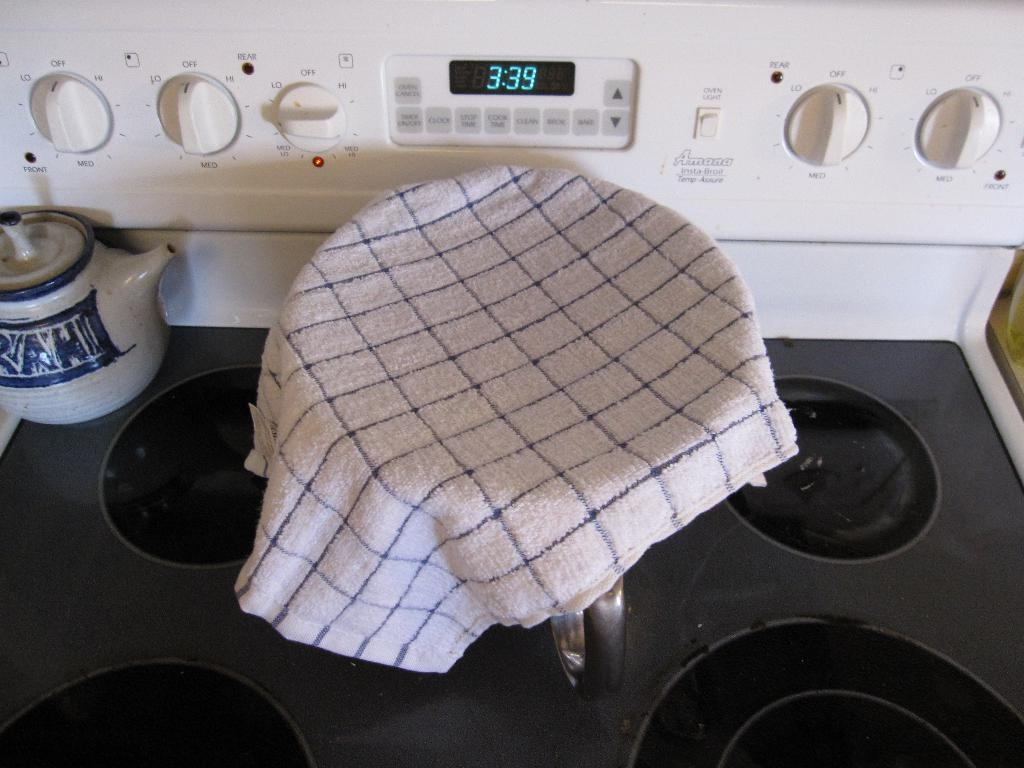<image>
Describe the image concisely. a clock that has the time of 3:39 on it 